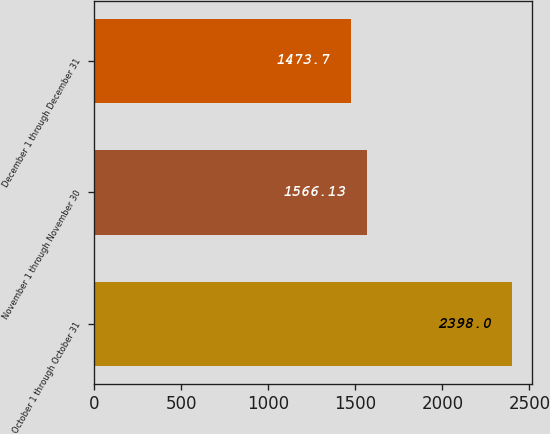Convert chart to OTSL. <chart><loc_0><loc_0><loc_500><loc_500><bar_chart><fcel>October 1 through October 31<fcel>November 1 through November 30<fcel>December 1 through December 31<nl><fcel>2398<fcel>1566.13<fcel>1473.7<nl></chart> 